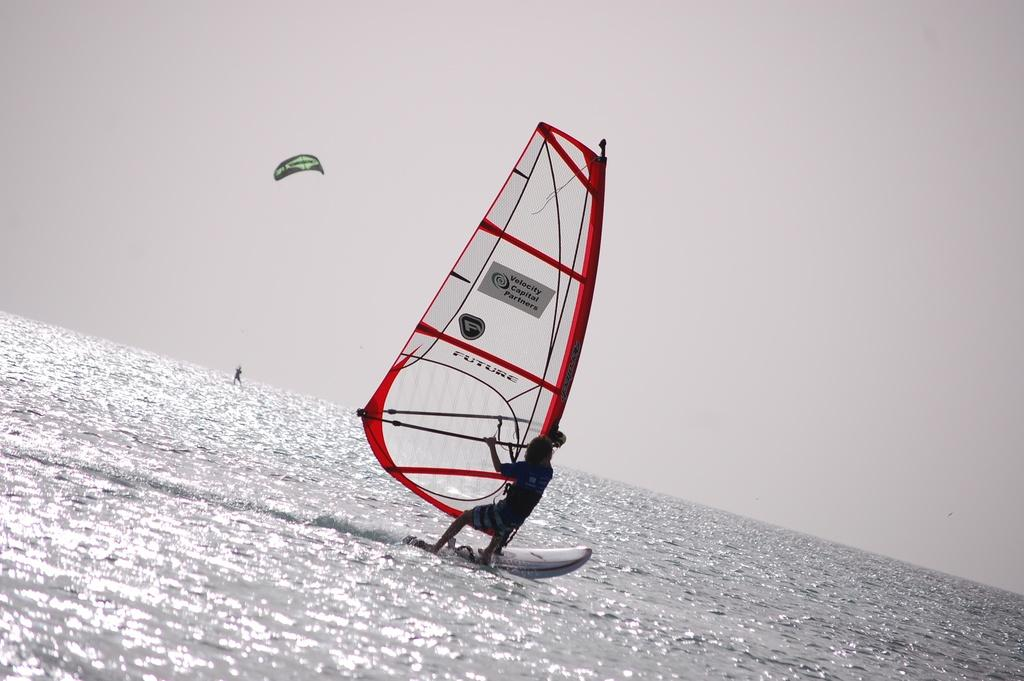What is the main activity being performed in the image? There is a person surfing on the water. What other water activity can be seen happening in the background? There is a parasailing activity happening in the background. What part of the natural environment is visible in the image? The sky is visible at the top of the image. How many parts of the surfboard are visible in the image? There is no specific mention of the surfboard's parts in the image, so it cannot be determined. --- Facts: 1. There is a person holding a camera. 2. The person is standing on a bridge. 3. There is a river flowing beneath the bridge. 4. There are trees on both sides of the river. Absurd Topics: dance, piano, melody Conversation: What is the person holding in the image? The person is holding a camera in the image. Where is the person standing in the image? The person is standing on a bridge in the image. What can be seen flowing beneath the bridge? There is a river flowing beneath the bridge in the image. What type of vegetation is present on both sides of the river? There are trees on both sides of the river in the image. Reasoning: Let's think step by step in order to produce the conversation. We start by identifying the main subject in the image, which is the person holding a camera. Then, we expand the conversation to include the location of the person (on a bridge) and the surrounding environment (river and trees). Each question is designed to elicit a specific detail about the image that is known from the provided facts. Absurd Question/Answer: What type of dance is being performed on the piano in the image? There is no piano or dance present in the image; it features a person holding a camera on a bridge. 